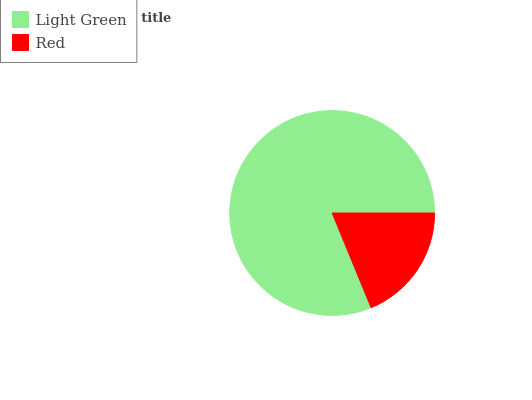Is Red the minimum?
Answer yes or no. Yes. Is Light Green the maximum?
Answer yes or no. Yes. Is Red the maximum?
Answer yes or no. No. Is Light Green greater than Red?
Answer yes or no. Yes. Is Red less than Light Green?
Answer yes or no. Yes. Is Red greater than Light Green?
Answer yes or no. No. Is Light Green less than Red?
Answer yes or no. No. Is Light Green the high median?
Answer yes or no. Yes. Is Red the low median?
Answer yes or no. Yes. Is Red the high median?
Answer yes or no. No. Is Light Green the low median?
Answer yes or no. No. 